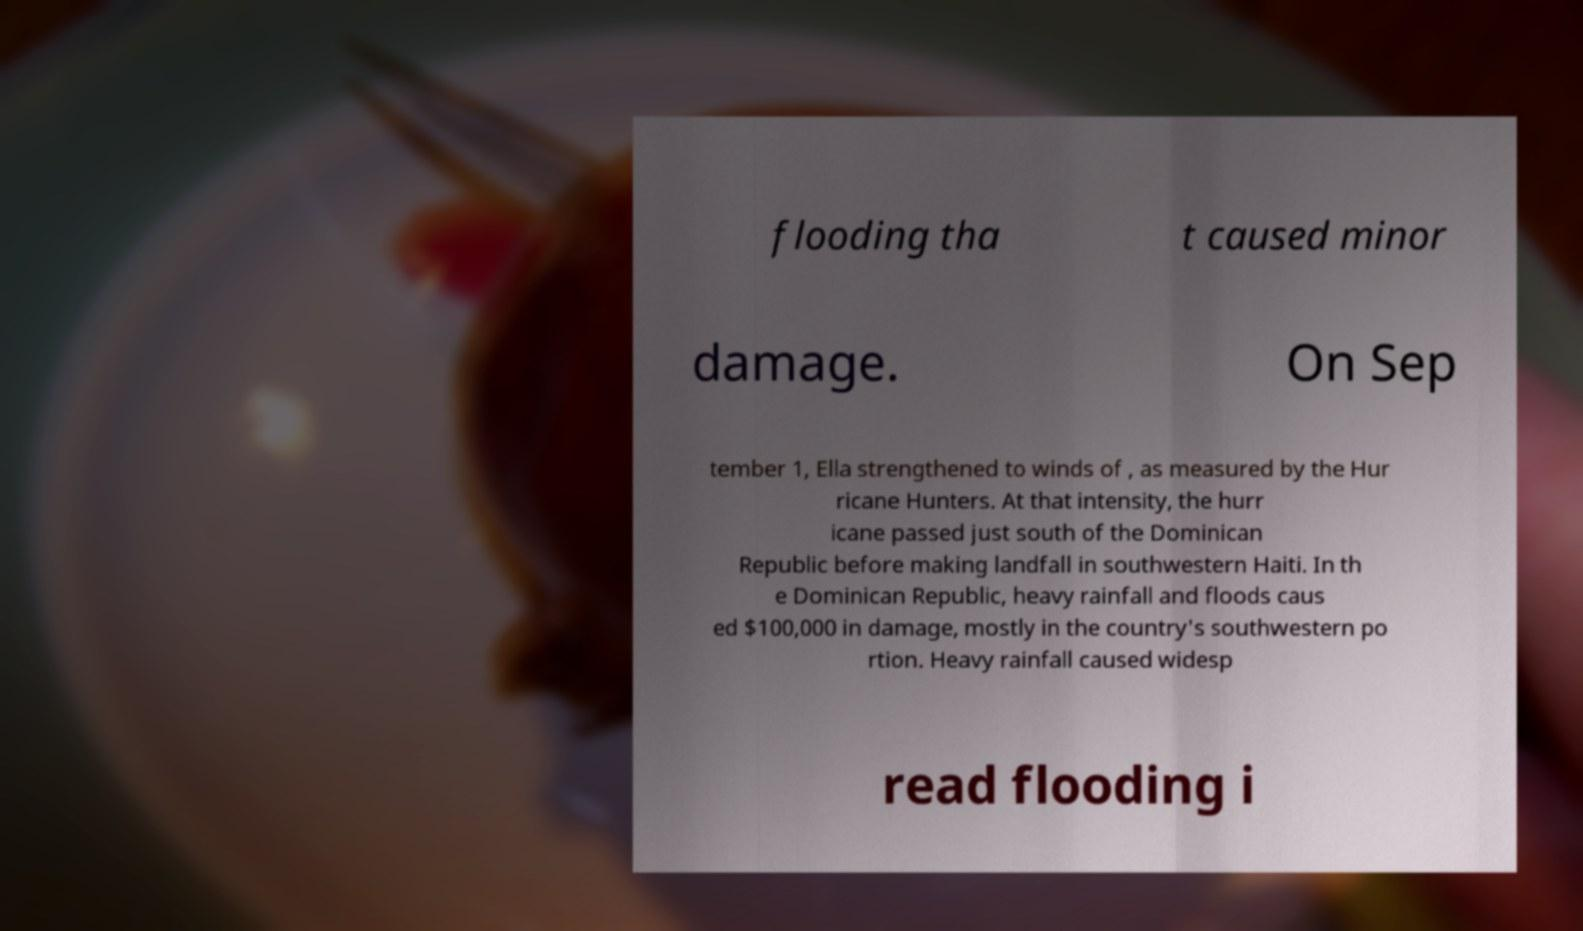For documentation purposes, I need the text within this image transcribed. Could you provide that? flooding tha t caused minor damage. On Sep tember 1, Ella strengthened to winds of , as measured by the Hur ricane Hunters. At that intensity, the hurr icane passed just south of the Dominican Republic before making landfall in southwestern Haiti. In th e Dominican Republic, heavy rainfall and floods caus ed $100,000 in damage, mostly in the country's southwestern po rtion. Heavy rainfall caused widesp read flooding i 